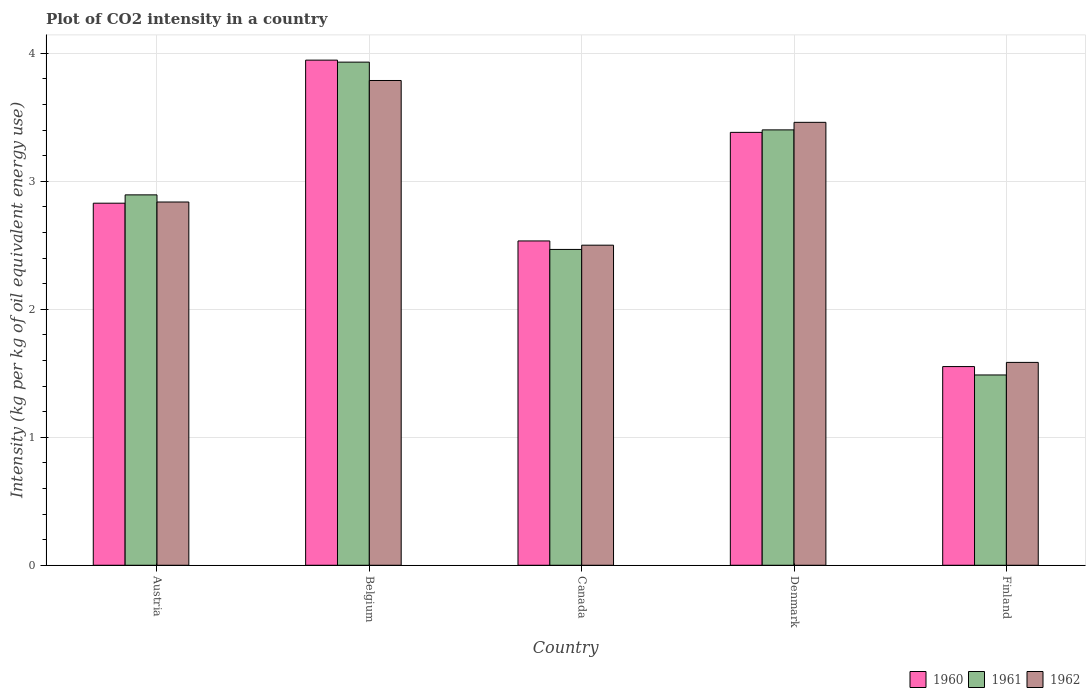Are the number of bars per tick equal to the number of legend labels?
Your answer should be very brief. Yes. How many bars are there on the 4th tick from the right?
Make the answer very short. 3. What is the label of the 1st group of bars from the left?
Offer a terse response. Austria. What is the CO2 intensity in in 1960 in Belgium?
Your response must be concise. 3.95. Across all countries, what is the maximum CO2 intensity in in 1962?
Offer a terse response. 3.79. Across all countries, what is the minimum CO2 intensity in in 1960?
Make the answer very short. 1.55. In which country was the CO2 intensity in in 1962 maximum?
Provide a short and direct response. Belgium. What is the total CO2 intensity in in 1961 in the graph?
Offer a terse response. 14.18. What is the difference between the CO2 intensity in in 1960 in Belgium and that in Canada?
Make the answer very short. 1.41. What is the difference between the CO2 intensity in in 1962 in Canada and the CO2 intensity in in 1960 in Austria?
Make the answer very short. -0.33. What is the average CO2 intensity in in 1961 per country?
Keep it short and to the point. 2.84. What is the difference between the CO2 intensity in of/in 1961 and CO2 intensity in of/in 1960 in Austria?
Keep it short and to the point. 0.07. What is the ratio of the CO2 intensity in in 1961 in Austria to that in Canada?
Your answer should be compact. 1.17. Is the difference between the CO2 intensity in in 1961 in Denmark and Finland greater than the difference between the CO2 intensity in in 1960 in Denmark and Finland?
Your answer should be compact. Yes. What is the difference between the highest and the second highest CO2 intensity in in 1961?
Your answer should be compact. 0.51. What is the difference between the highest and the lowest CO2 intensity in in 1960?
Give a very brief answer. 2.39. What does the 2nd bar from the left in Denmark represents?
Ensure brevity in your answer.  1961. Is it the case that in every country, the sum of the CO2 intensity in in 1960 and CO2 intensity in in 1962 is greater than the CO2 intensity in in 1961?
Your answer should be compact. Yes. How many bars are there?
Make the answer very short. 15. Are the values on the major ticks of Y-axis written in scientific E-notation?
Keep it short and to the point. No. Where does the legend appear in the graph?
Give a very brief answer. Bottom right. How many legend labels are there?
Your answer should be very brief. 3. How are the legend labels stacked?
Give a very brief answer. Horizontal. What is the title of the graph?
Offer a terse response. Plot of CO2 intensity in a country. Does "2003" appear as one of the legend labels in the graph?
Provide a short and direct response. No. What is the label or title of the X-axis?
Give a very brief answer. Country. What is the label or title of the Y-axis?
Offer a terse response. Intensity (kg per kg of oil equivalent energy use). What is the Intensity (kg per kg of oil equivalent energy use) of 1960 in Austria?
Your answer should be very brief. 2.83. What is the Intensity (kg per kg of oil equivalent energy use) of 1961 in Austria?
Provide a short and direct response. 2.89. What is the Intensity (kg per kg of oil equivalent energy use) of 1962 in Austria?
Ensure brevity in your answer.  2.84. What is the Intensity (kg per kg of oil equivalent energy use) of 1960 in Belgium?
Make the answer very short. 3.95. What is the Intensity (kg per kg of oil equivalent energy use) in 1961 in Belgium?
Offer a terse response. 3.93. What is the Intensity (kg per kg of oil equivalent energy use) in 1962 in Belgium?
Give a very brief answer. 3.79. What is the Intensity (kg per kg of oil equivalent energy use) in 1960 in Canada?
Give a very brief answer. 2.53. What is the Intensity (kg per kg of oil equivalent energy use) of 1961 in Canada?
Provide a short and direct response. 2.47. What is the Intensity (kg per kg of oil equivalent energy use) of 1962 in Canada?
Provide a short and direct response. 2.5. What is the Intensity (kg per kg of oil equivalent energy use) of 1960 in Denmark?
Ensure brevity in your answer.  3.38. What is the Intensity (kg per kg of oil equivalent energy use) of 1961 in Denmark?
Give a very brief answer. 3.4. What is the Intensity (kg per kg of oil equivalent energy use) of 1962 in Denmark?
Give a very brief answer. 3.46. What is the Intensity (kg per kg of oil equivalent energy use) of 1960 in Finland?
Your response must be concise. 1.55. What is the Intensity (kg per kg of oil equivalent energy use) in 1961 in Finland?
Your answer should be very brief. 1.49. What is the Intensity (kg per kg of oil equivalent energy use) in 1962 in Finland?
Provide a succinct answer. 1.58. Across all countries, what is the maximum Intensity (kg per kg of oil equivalent energy use) in 1960?
Keep it short and to the point. 3.95. Across all countries, what is the maximum Intensity (kg per kg of oil equivalent energy use) of 1961?
Offer a terse response. 3.93. Across all countries, what is the maximum Intensity (kg per kg of oil equivalent energy use) in 1962?
Your answer should be compact. 3.79. Across all countries, what is the minimum Intensity (kg per kg of oil equivalent energy use) of 1960?
Offer a very short reply. 1.55. Across all countries, what is the minimum Intensity (kg per kg of oil equivalent energy use) of 1961?
Offer a terse response. 1.49. Across all countries, what is the minimum Intensity (kg per kg of oil equivalent energy use) in 1962?
Provide a succinct answer. 1.58. What is the total Intensity (kg per kg of oil equivalent energy use) of 1960 in the graph?
Provide a succinct answer. 14.24. What is the total Intensity (kg per kg of oil equivalent energy use) of 1961 in the graph?
Ensure brevity in your answer.  14.18. What is the total Intensity (kg per kg of oil equivalent energy use) in 1962 in the graph?
Your response must be concise. 14.17. What is the difference between the Intensity (kg per kg of oil equivalent energy use) in 1960 in Austria and that in Belgium?
Offer a terse response. -1.12. What is the difference between the Intensity (kg per kg of oil equivalent energy use) in 1961 in Austria and that in Belgium?
Provide a short and direct response. -1.04. What is the difference between the Intensity (kg per kg of oil equivalent energy use) in 1962 in Austria and that in Belgium?
Your answer should be compact. -0.95. What is the difference between the Intensity (kg per kg of oil equivalent energy use) in 1960 in Austria and that in Canada?
Offer a terse response. 0.29. What is the difference between the Intensity (kg per kg of oil equivalent energy use) in 1961 in Austria and that in Canada?
Keep it short and to the point. 0.43. What is the difference between the Intensity (kg per kg of oil equivalent energy use) in 1962 in Austria and that in Canada?
Your answer should be compact. 0.34. What is the difference between the Intensity (kg per kg of oil equivalent energy use) in 1960 in Austria and that in Denmark?
Make the answer very short. -0.55. What is the difference between the Intensity (kg per kg of oil equivalent energy use) in 1961 in Austria and that in Denmark?
Offer a terse response. -0.51. What is the difference between the Intensity (kg per kg of oil equivalent energy use) of 1962 in Austria and that in Denmark?
Your response must be concise. -0.62. What is the difference between the Intensity (kg per kg of oil equivalent energy use) in 1960 in Austria and that in Finland?
Give a very brief answer. 1.28. What is the difference between the Intensity (kg per kg of oil equivalent energy use) in 1961 in Austria and that in Finland?
Your answer should be compact. 1.41. What is the difference between the Intensity (kg per kg of oil equivalent energy use) of 1962 in Austria and that in Finland?
Offer a very short reply. 1.25. What is the difference between the Intensity (kg per kg of oil equivalent energy use) in 1960 in Belgium and that in Canada?
Make the answer very short. 1.41. What is the difference between the Intensity (kg per kg of oil equivalent energy use) of 1961 in Belgium and that in Canada?
Provide a short and direct response. 1.46. What is the difference between the Intensity (kg per kg of oil equivalent energy use) of 1962 in Belgium and that in Canada?
Provide a succinct answer. 1.29. What is the difference between the Intensity (kg per kg of oil equivalent energy use) of 1960 in Belgium and that in Denmark?
Your answer should be compact. 0.56. What is the difference between the Intensity (kg per kg of oil equivalent energy use) in 1961 in Belgium and that in Denmark?
Provide a succinct answer. 0.53. What is the difference between the Intensity (kg per kg of oil equivalent energy use) in 1962 in Belgium and that in Denmark?
Offer a terse response. 0.33. What is the difference between the Intensity (kg per kg of oil equivalent energy use) of 1960 in Belgium and that in Finland?
Provide a short and direct response. 2.39. What is the difference between the Intensity (kg per kg of oil equivalent energy use) of 1961 in Belgium and that in Finland?
Your response must be concise. 2.44. What is the difference between the Intensity (kg per kg of oil equivalent energy use) of 1962 in Belgium and that in Finland?
Provide a succinct answer. 2.2. What is the difference between the Intensity (kg per kg of oil equivalent energy use) in 1960 in Canada and that in Denmark?
Your answer should be compact. -0.85. What is the difference between the Intensity (kg per kg of oil equivalent energy use) in 1961 in Canada and that in Denmark?
Give a very brief answer. -0.93. What is the difference between the Intensity (kg per kg of oil equivalent energy use) in 1962 in Canada and that in Denmark?
Provide a succinct answer. -0.96. What is the difference between the Intensity (kg per kg of oil equivalent energy use) in 1960 in Canada and that in Finland?
Your response must be concise. 0.98. What is the difference between the Intensity (kg per kg of oil equivalent energy use) of 1961 in Canada and that in Finland?
Your response must be concise. 0.98. What is the difference between the Intensity (kg per kg of oil equivalent energy use) of 1962 in Canada and that in Finland?
Make the answer very short. 0.92. What is the difference between the Intensity (kg per kg of oil equivalent energy use) in 1960 in Denmark and that in Finland?
Make the answer very short. 1.83. What is the difference between the Intensity (kg per kg of oil equivalent energy use) of 1961 in Denmark and that in Finland?
Make the answer very short. 1.91. What is the difference between the Intensity (kg per kg of oil equivalent energy use) of 1962 in Denmark and that in Finland?
Give a very brief answer. 1.88. What is the difference between the Intensity (kg per kg of oil equivalent energy use) of 1960 in Austria and the Intensity (kg per kg of oil equivalent energy use) of 1961 in Belgium?
Ensure brevity in your answer.  -1.1. What is the difference between the Intensity (kg per kg of oil equivalent energy use) in 1960 in Austria and the Intensity (kg per kg of oil equivalent energy use) in 1962 in Belgium?
Make the answer very short. -0.96. What is the difference between the Intensity (kg per kg of oil equivalent energy use) of 1961 in Austria and the Intensity (kg per kg of oil equivalent energy use) of 1962 in Belgium?
Offer a very short reply. -0.89. What is the difference between the Intensity (kg per kg of oil equivalent energy use) in 1960 in Austria and the Intensity (kg per kg of oil equivalent energy use) in 1961 in Canada?
Provide a short and direct response. 0.36. What is the difference between the Intensity (kg per kg of oil equivalent energy use) of 1960 in Austria and the Intensity (kg per kg of oil equivalent energy use) of 1962 in Canada?
Keep it short and to the point. 0.33. What is the difference between the Intensity (kg per kg of oil equivalent energy use) in 1961 in Austria and the Intensity (kg per kg of oil equivalent energy use) in 1962 in Canada?
Provide a succinct answer. 0.39. What is the difference between the Intensity (kg per kg of oil equivalent energy use) of 1960 in Austria and the Intensity (kg per kg of oil equivalent energy use) of 1961 in Denmark?
Your answer should be very brief. -0.57. What is the difference between the Intensity (kg per kg of oil equivalent energy use) in 1960 in Austria and the Intensity (kg per kg of oil equivalent energy use) in 1962 in Denmark?
Keep it short and to the point. -0.63. What is the difference between the Intensity (kg per kg of oil equivalent energy use) in 1961 in Austria and the Intensity (kg per kg of oil equivalent energy use) in 1962 in Denmark?
Provide a succinct answer. -0.57. What is the difference between the Intensity (kg per kg of oil equivalent energy use) in 1960 in Austria and the Intensity (kg per kg of oil equivalent energy use) in 1961 in Finland?
Keep it short and to the point. 1.34. What is the difference between the Intensity (kg per kg of oil equivalent energy use) in 1960 in Austria and the Intensity (kg per kg of oil equivalent energy use) in 1962 in Finland?
Your answer should be very brief. 1.24. What is the difference between the Intensity (kg per kg of oil equivalent energy use) of 1961 in Austria and the Intensity (kg per kg of oil equivalent energy use) of 1962 in Finland?
Your answer should be compact. 1.31. What is the difference between the Intensity (kg per kg of oil equivalent energy use) in 1960 in Belgium and the Intensity (kg per kg of oil equivalent energy use) in 1961 in Canada?
Your response must be concise. 1.48. What is the difference between the Intensity (kg per kg of oil equivalent energy use) of 1960 in Belgium and the Intensity (kg per kg of oil equivalent energy use) of 1962 in Canada?
Your answer should be compact. 1.45. What is the difference between the Intensity (kg per kg of oil equivalent energy use) of 1961 in Belgium and the Intensity (kg per kg of oil equivalent energy use) of 1962 in Canada?
Give a very brief answer. 1.43. What is the difference between the Intensity (kg per kg of oil equivalent energy use) in 1960 in Belgium and the Intensity (kg per kg of oil equivalent energy use) in 1961 in Denmark?
Your answer should be very brief. 0.54. What is the difference between the Intensity (kg per kg of oil equivalent energy use) in 1960 in Belgium and the Intensity (kg per kg of oil equivalent energy use) in 1962 in Denmark?
Provide a succinct answer. 0.49. What is the difference between the Intensity (kg per kg of oil equivalent energy use) of 1961 in Belgium and the Intensity (kg per kg of oil equivalent energy use) of 1962 in Denmark?
Offer a very short reply. 0.47. What is the difference between the Intensity (kg per kg of oil equivalent energy use) of 1960 in Belgium and the Intensity (kg per kg of oil equivalent energy use) of 1961 in Finland?
Make the answer very short. 2.46. What is the difference between the Intensity (kg per kg of oil equivalent energy use) in 1960 in Belgium and the Intensity (kg per kg of oil equivalent energy use) in 1962 in Finland?
Make the answer very short. 2.36. What is the difference between the Intensity (kg per kg of oil equivalent energy use) of 1961 in Belgium and the Intensity (kg per kg of oil equivalent energy use) of 1962 in Finland?
Offer a very short reply. 2.35. What is the difference between the Intensity (kg per kg of oil equivalent energy use) in 1960 in Canada and the Intensity (kg per kg of oil equivalent energy use) in 1961 in Denmark?
Your answer should be very brief. -0.87. What is the difference between the Intensity (kg per kg of oil equivalent energy use) in 1960 in Canada and the Intensity (kg per kg of oil equivalent energy use) in 1962 in Denmark?
Offer a terse response. -0.93. What is the difference between the Intensity (kg per kg of oil equivalent energy use) in 1961 in Canada and the Intensity (kg per kg of oil equivalent energy use) in 1962 in Denmark?
Keep it short and to the point. -0.99. What is the difference between the Intensity (kg per kg of oil equivalent energy use) of 1960 in Canada and the Intensity (kg per kg of oil equivalent energy use) of 1961 in Finland?
Provide a succinct answer. 1.05. What is the difference between the Intensity (kg per kg of oil equivalent energy use) in 1960 in Canada and the Intensity (kg per kg of oil equivalent energy use) in 1962 in Finland?
Offer a terse response. 0.95. What is the difference between the Intensity (kg per kg of oil equivalent energy use) in 1961 in Canada and the Intensity (kg per kg of oil equivalent energy use) in 1962 in Finland?
Your answer should be very brief. 0.88. What is the difference between the Intensity (kg per kg of oil equivalent energy use) of 1960 in Denmark and the Intensity (kg per kg of oil equivalent energy use) of 1961 in Finland?
Ensure brevity in your answer.  1.9. What is the difference between the Intensity (kg per kg of oil equivalent energy use) of 1960 in Denmark and the Intensity (kg per kg of oil equivalent energy use) of 1962 in Finland?
Offer a terse response. 1.8. What is the difference between the Intensity (kg per kg of oil equivalent energy use) of 1961 in Denmark and the Intensity (kg per kg of oil equivalent energy use) of 1962 in Finland?
Ensure brevity in your answer.  1.82. What is the average Intensity (kg per kg of oil equivalent energy use) in 1960 per country?
Provide a short and direct response. 2.85. What is the average Intensity (kg per kg of oil equivalent energy use) in 1961 per country?
Keep it short and to the point. 2.84. What is the average Intensity (kg per kg of oil equivalent energy use) of 1962 per country?
Give a very brief answer. 2.83. What is the difference between the Intensity (kg per kg of oil equivalent energy use) in 1960 and Intensity (kg per kg of oil equivalent energy use) in 1961 in Austria?
Ensure brevity in your answer.  -0.07. What is the difference between the Intensity (kg per kg of oil equivalent energy use) of 1960 and Intensity (kg per kg of oil equivalent energy use) of 1962 in Austria?
Offer a terse response. -0.01. What is the difference between the Intensity (kg per kg of oil equivalent energy use) in 1961 and Intensity (kg per kg of oil equivalent energy use) in 1962 in Austria?
Provide a short and direct response. 0.06. What is the difference between the Intensity (kg per kg of oil equivalent energy use) in 1960 and Intensity (kg per kg of oil equivalent energy use) in 1961 in Belgium?
Give a very brief answer. 0.02. What is the difference between the Intensity (kg per kg of oil equivalent energy use) of 1960 and Intensity (kg per kg of oil equivalent energy use) of 1962 in Belgium?
Your response must be concise. 0.16. What is the difference between the Intensity (kg per kg of oil equivalent energy use) of 1961 and Intensity (kg per kg of oil equivalent energy use) of 1962 in Belgium?
Provide a short and direct response. 0.14. What is the difference between the Intensity (kg per kg of oil equivalent energy use) of 1960 and Intensity (kg per kg of oil equivalent energy use) of 1961 in Canada?
Your answer should be very brief. 0.07. What is the difference between the Intensity (kg per kg of oil equivalent energy use) in 1960 and Intensity (kg per kg of oil equivalent energy use) in 1962 in Canada?
Your answer should be very brief. 0.03. What is the difference between the Intensity (kg per kg of oil equivalent energy use) in 1961 and Intensity (kg per kg of oil equivalent energy use) in 1962 in Canada?
Give a very brief answer. -0.03. What is the difference between the Intensity (kg per kg of oil equivalent energy use) of 1960 and Intensity (kg per kg of oil equivalent energy use) of 1961 in Denmark?
Offer a terse response. -0.02. What is the difference between the Intensity (kg per kg of oil equivalent energy use) of 1960 and Intensity (kg per kg of oil equivalent energy use) of 1962 in Denmark?
Your response must be concise. -0.08. What is the difference between the Intensity (kg per kg of oil equivalent energy use) in 1961 and Intensity (kg per kg of oil equivalent energy use) in 1962 in Denmark?
Your response must be concise. -0.06. What is the difference between the Intensity (kg per kg of oil equivalent energy use) of 1960 and Intensity (kg per kg of oil equivalent energy use) of 1961 in Finland?
Keep it short and to the point. 0.07. What is the difference between the Intensity (kg per kg of oil equivalent energy use) in 1960 and Intensity (kg per kg of oil equivalent energy use) in 1962 in Finland?
Ensure brevity in your answer.  -0.03. What is the difference between the Intensity (kg per kg of oil equivalent energy use) in 1961 and Intensity (kg per kg of oil equivalent energy use) in 1962 in Finland?
Offer a terse response. -0.1. What is the ratio of the Intensity (kg per kg of oil equivalent energy use) in 1960 in Austria to that in Belgium?
Your answer should be compact. 0.72. What is the ratio of the Intensity (kg per kg of oil equivalent energy use) in 1961 in Austria to that in Belgium?
Offer a terse response. 0.74. What is the ratio of the Intensity (kg per kg of oil equivalent energy use) in 1962 in Austria to that in Belgium?
Offer a very short reply. 0.75. What is the ratio of the Intensity (kg per kg of oil equivalent energy use) in 1960 in Austria to that in Canada?
Give a very brief answer. 1.12. What is the ratio of the Intensity (kg per kg of oil equivalent energy use) of 1961 in Austria to that in Canada?
Your response must be concise. 1.17. What is the ratio of the Intensity (kg per kg of oil equivalent energy use) of 1962 in Austria to that in Canada?
Keep it short and to the point. 1.13. What is the ratio of the Intensity (kg per kg of oil equivalent energy use) of 1960 in Austria to that in Denmark?
Provide a succinct answer. 0.84. What is the ratio of the Intensity (kg per kg of oil equivalent energy use) in 1961 in Austria to that in Denmark?
Provide a succinct answer. 0.85. What is the ratio of the Intensity (kg per kg of oil equivalent energy use) in 1962 in Austria to that in Denmark?
Keep it short and to the point. 0.82. What is the ratio of the Intensity (kg per kg of oil equivalent energy use) of 1960 in Austria to that in Finland?
Give a very brief answer. 1.82. What is the ratio of the Intensity (kg per kg of oil equivalent energy use) in 1961 in Austria to that in Finland?
Provide a short and direct response. 1.95. What is the ratio of the Intensity (kg per kg of oil equivalent energy use) in 1962 in Austria to that in Finland?
Give a very brief answer. 1.79. What is the ratio of the Intensity (kg per kg of oil equivalent energy use) of 1960 in Belgium to that in Canada?
Keep it short and to the point. 1.56. What is the ratio of the Intensity (kg per kg of oil equivalent energy use) in 1961 in Belgium to that in Canada?
Provide a succinct answer. 1.59. What is the ratio of the Intensity (kg per kg of oil equivalent energy use) of 1962 in Belgium to that in Canada?
Give a very brief answer. 1.51. What is the ratio of the Intensity (kg per kg of oil equivalent energy use) of 1960 in Belgium to that in Denmark?
Keep it short and to the point. 1.17. What is the ratio of the Intensity (kg per kg of oil equivalent energy use) of 1961 in Belgium to that in Denmark?
Your answer should be very brief. 1.16. What is the ratio of the Intensity (kg per kg of oil equivalent energy use) of 1962 in Belgium to that in Denmark?
Make the answer very short. 1.09. What is the ratio of the Intensity (kg per kg of oil equivalent energy use) in 1960 in Belgium to that in Finland?
Provide a short and direct response. 2.54. What is the ratio of the Intensity (kg per kg of oil equivalent energy use) in 1961 in Belgium to that in Finland?
Offer a terse response. 2.64. What is the ratio of the Intensity (kg per kg of oil equivalent energy use) of 1962 in Belgium to that in Finland?
Keep it short and to the point. 2.39. What is the ratio of the Intensity (kg per kg of oil equivalent energy use) in 1960 in Canada to that in Denmark?
Offer a very short reply. 0.75. What is the ratio of the Intensity (kg per kg of oil equivalent energy use) in 1961 in Canada to that in Denmark?
Keep it short and to the point. 0.73. What is the ratio of the Intensity (kg per kg of oil equivalent energy use) of 1962 in Canada to that in Denmark?
Provide a short and direct response. 0.72. What is the ratio of the Intensity (kg per kg of oil equivalent energy use) of 1960 in Canada to that in Finland?
Your response must be concise. 1.63. What is the ratio of the Intensity (kg per kg of oil equivalent energy use) of 1961 in Canada to that in Finland?
Make the answer very short. 1.66. What is the ratio of the Intensity (kg per kg of oil equivalent energy use) of 1962 in Canada to that in Finland?
Your response must be concise. 1.58. What is the ratio of the Intensity (kg per kg of oil equivalent energy use) in 1960 in Denmark to that in Finland?
Provide a short and direct response. 2.18. What is the ratio of the Intensity (kg per kg of oil equivalent energy use) of 1961 in Denmark to that in Finland?
Offer a very short reply. 2.29. What is the ratio of the Intensity (kg per kg of oil equivalent energy use) of 1962 in Denmark to that in Finland?
Give a very brief answer. 2.18. What is the difference between the highest and the second highest Intensity (kg per kg of oil equivalent energy use) of 1960?
Offer a very short reply. 0.56. What is the difference between the highest and the second highest Intensity (kg per kg of oil equivalent energy use) in 1961?
Give a very brief answer. 0.53. What is the difference between the highest and the second highest Intensity (kg per kg of oil equivalent energy use) of 1962?
Your answer should be compact. 0.33. What is the difference between the highest and the lowest Intensity (kg per kg of oil equivalent energy use) of 1960?
Your answer should be very brief. 2.39. What is the difference between the highest and the lowest Intensity (kg per kg of oil equivalent energy use) in 1961?
Give a very brief answer. 2.44. What is the difference between the highest and the lowest Intensity (kg per kg of oil equivalent energy use) of 1962?
Your answer should be very brief. 2.2. 